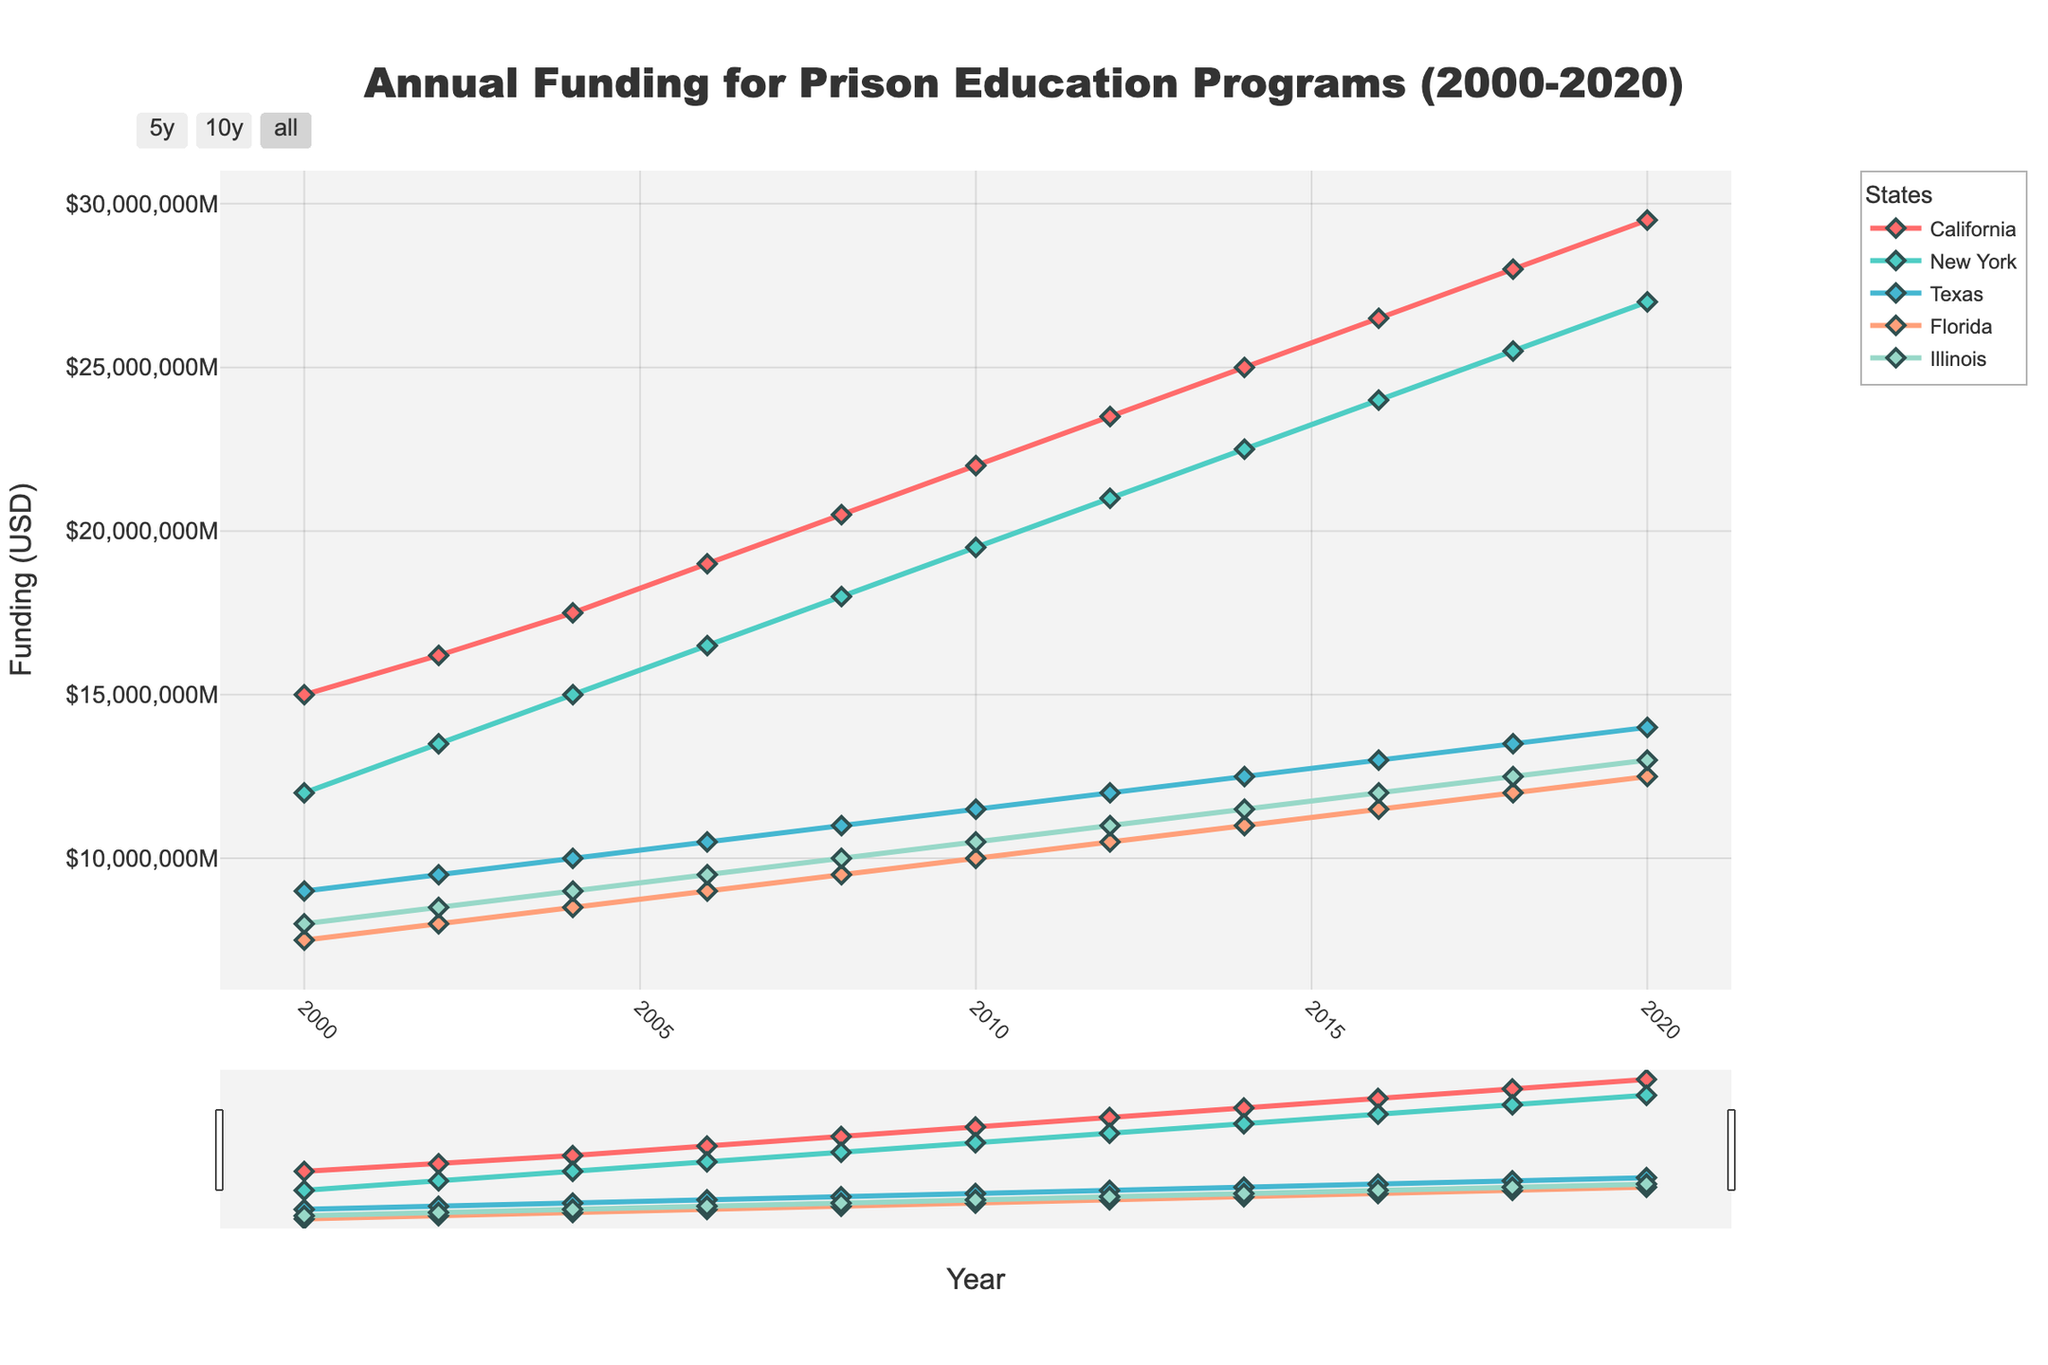What's the trend for California from 2000 to 2020? Looking at the red line representing California, the trend shows a steady increase in funding from $15,000,000 in 2000 to $29,500,000 in 2020.
Answer: Steady increase How does New York's funding in 2020 compare to Florida's funding in 2018? New York's funding in 2020 is the point marked near $27,000,000, and Florida's funding in 2018 is around $12,000,000. Comparing these values, New York's 2020 funding is more than twice that of Florida's 2018 funding.
Answer: New York's funding is more than twice In which year did Texas surpass the $10,000,000 funding mark? Referring to the green line representing Texas, it surpassed the $10,000,000 mark in 2006.
Answer: 2006 What is the average annual funding for Illinois from 2010 to 2020? To find the average, sum the values of Illinois' funding from 2010 to 2020 and divide by the number of years: ($10,500,000 + $11,000,000 + $11,500,000 + $12,000,000 + $12,500,000 + $13,000,000) / 6 = $11,750,000.
Answer: $11,750,000 How much more funding did California receive in 2020 compared to 2000? California received $29,500,000 in 2020 and $15,000,000 in 2000. The difference is $29,500,000 - $15,000,000 = $14,500,000.
Answer: $14,500,000 Which state had the highest increase in funding from 2000 to 2020? Analyze the increases for each state: 
- California: $29,500,000 - $15,000,000 = $14,500,000
- New York: $27,000,000 - $12,000,000 = $15,000,000
- Texas: $14,000,000 - $9,000,000 = $5,000,000
- Florida: $12,500,000 - $7,500,000 = $5,000,000
- Illinois: $13,000,000 - $8,000,000 = $5,000,000
New York had the highest increase of $15,000,000.
Answer: New York Which state's funding remained consistently the lowest from 2000 to 2020? Texas had consistently lower funding compared to other states throughout the years, except before surpassing Florida and Illinois in the early 2000s.
Answer: Texas What is the total funding for New York from 2000 to 2020? Sum all the values for New York's funding: $12,000,000 + $13,500,000 + $15,000,000 + $16,500,000 + $18,000,000 + $19,500,000 + $21,000,000 + $22,500,000 + $24,000,000 + $25,500,000 + $27,000,000 = $214,500,000.
Answer: $214,500,000 During which year did all states show an upward trend simultaneously? All states show an upward trend simultaneously in 2008 as indicated by the corresponding lines on the plot for that year.
Answer: 2008 